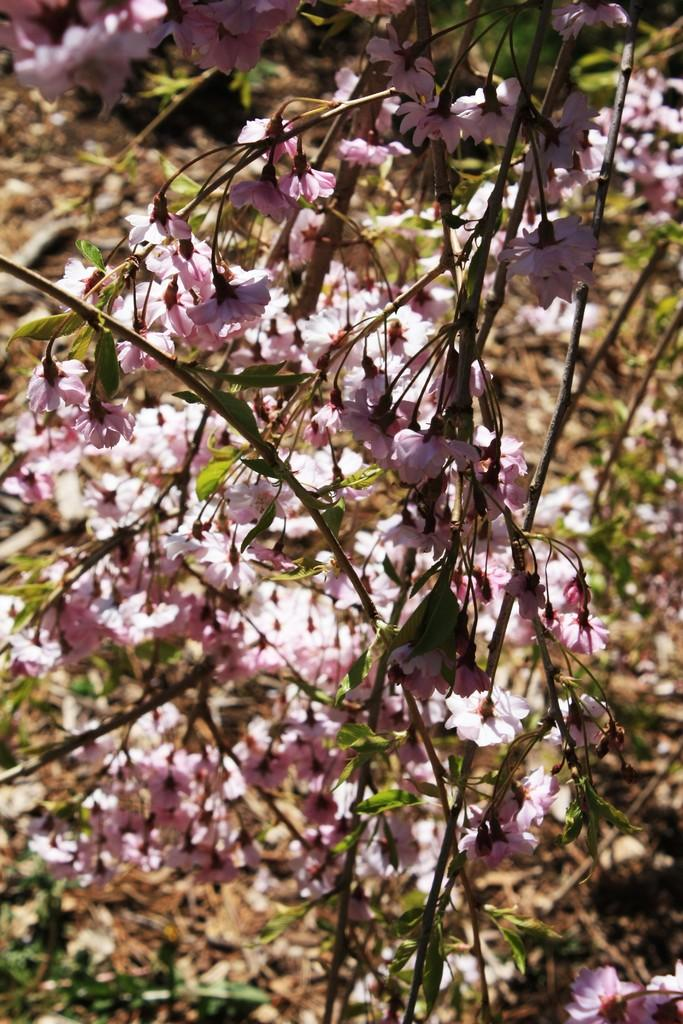What can be seen in the foreground of the image? There are flowers and a tree in the foreground of the image. What is visible in the background of the image? There are plants and dry leaves in the background of the image. What type of quartz can be seen in the image? There is no quartz present in the image. Can you hear the voice of the tree in the image? The image is a still picture and does not contain any sounds, so it is not possible to hear the voice of the tree. 